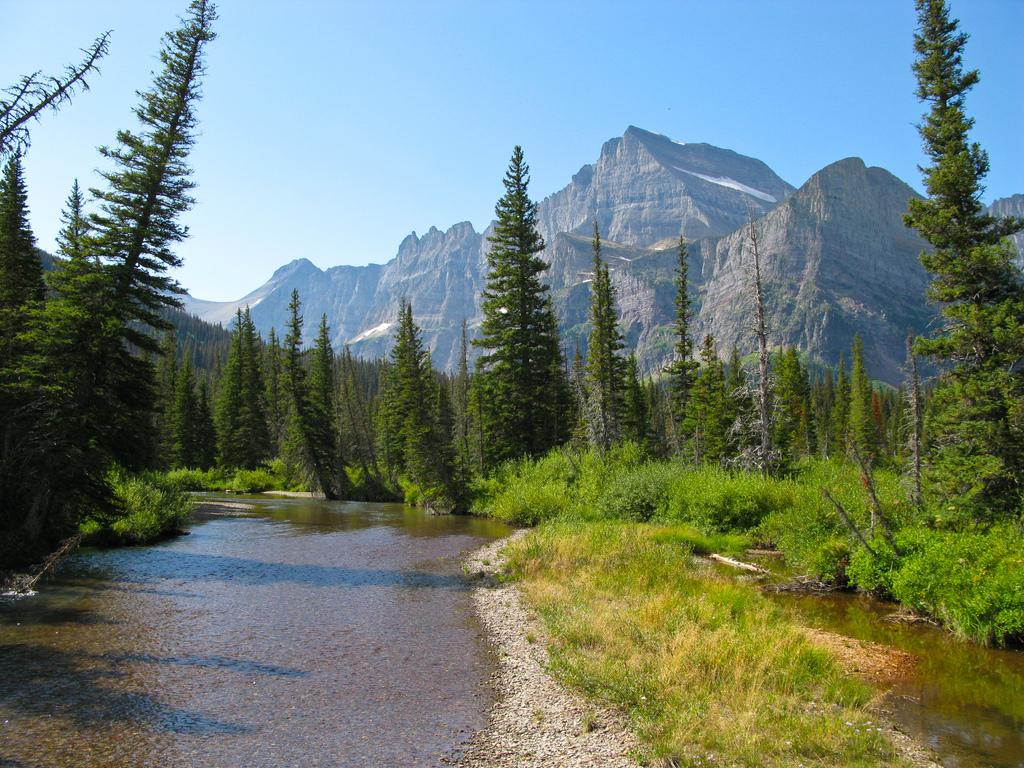What type of vegetation is present in the image? There is grass in the image. What else can be seen in the image besides grass? There is water in the image. What can be seen in the background of the image? There are trees and mountains in the background of the image. What part of the natural environment is visible in the image? The sky is visible in the background of the image. What type of quilt is being used as a prop in the image? There is no quilt present in the image. What title is given to the image? The image does not have a title, as it is not a piece of artwork or literature. 